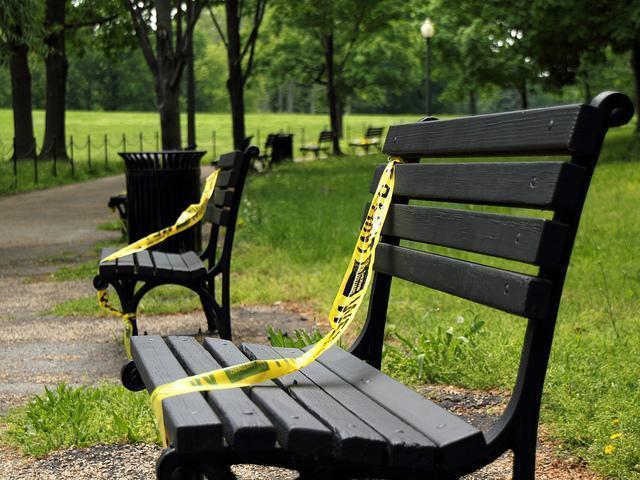For what reason were the benches likely sealed off with caution tape?
Answer the question by selecting the correct answer among the 4 following choices and explain your choice with a short sentence. The answer should be formatted with the following format: `Answer: choice
Rationale: rationale.`
Options: Rain, private, broken, wet paint. Answer: wet paint.
Rationale: The benches are outside, in good shape, and accessible by the public. the coating on the benches is brand new. 